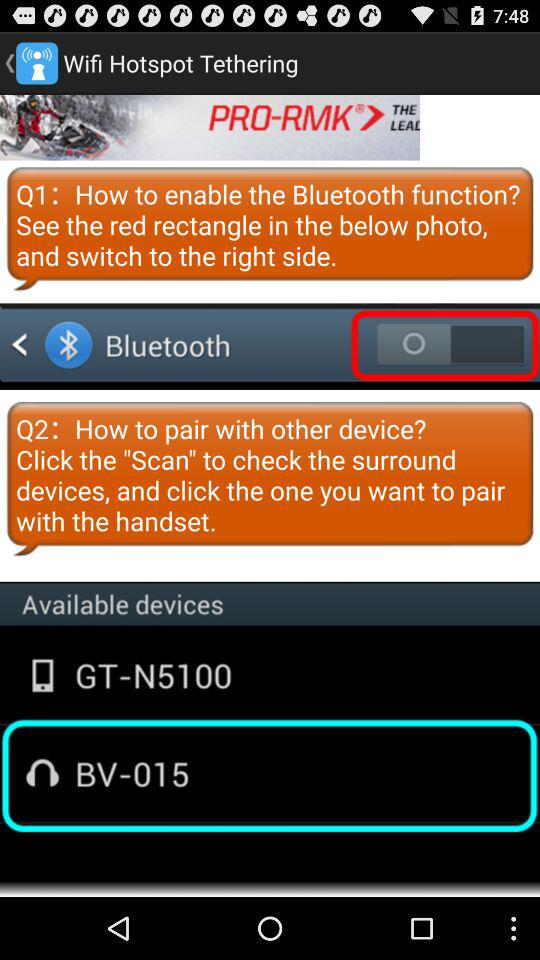Which WiFi name is selected?
When the provided information is insufficient, respond with <no answer>. <no answer> 